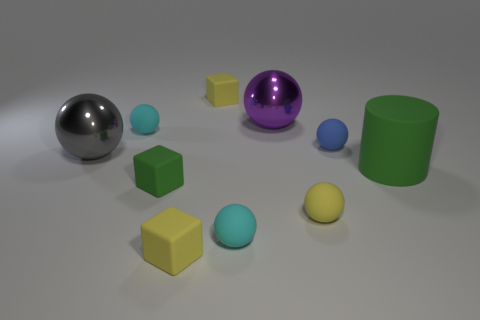Subtract all blue spheres. How many spheres are left? 5 Subtract all blue balls. How many balls are left? 5 Subtract 2 balls. How many balls are left? 4 Subtract all gray spheres. Subtract all yellow cylinders. How many spheres are left? 5 Subtract all spheres. How many objects are left? 4 Subtract 0 gray blocks. How many objects are left? 10 Subtract all rubber balls. Subtract all large purple shiny spheres. How many objects are left? 5 Add 9 big gray shiny spheres. How many big gray shiny spheres are left? 10 Add 5 green rubber things. How many green rubber things exist? 7 